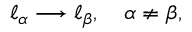Convert formula to latex. <formula><loc_0><loc_0><loc_500><loc_500>\ell _ { \alpha } \longrightarrow \ell _ { \beta } , \quad \alpha \ne \beta ,</formula> 